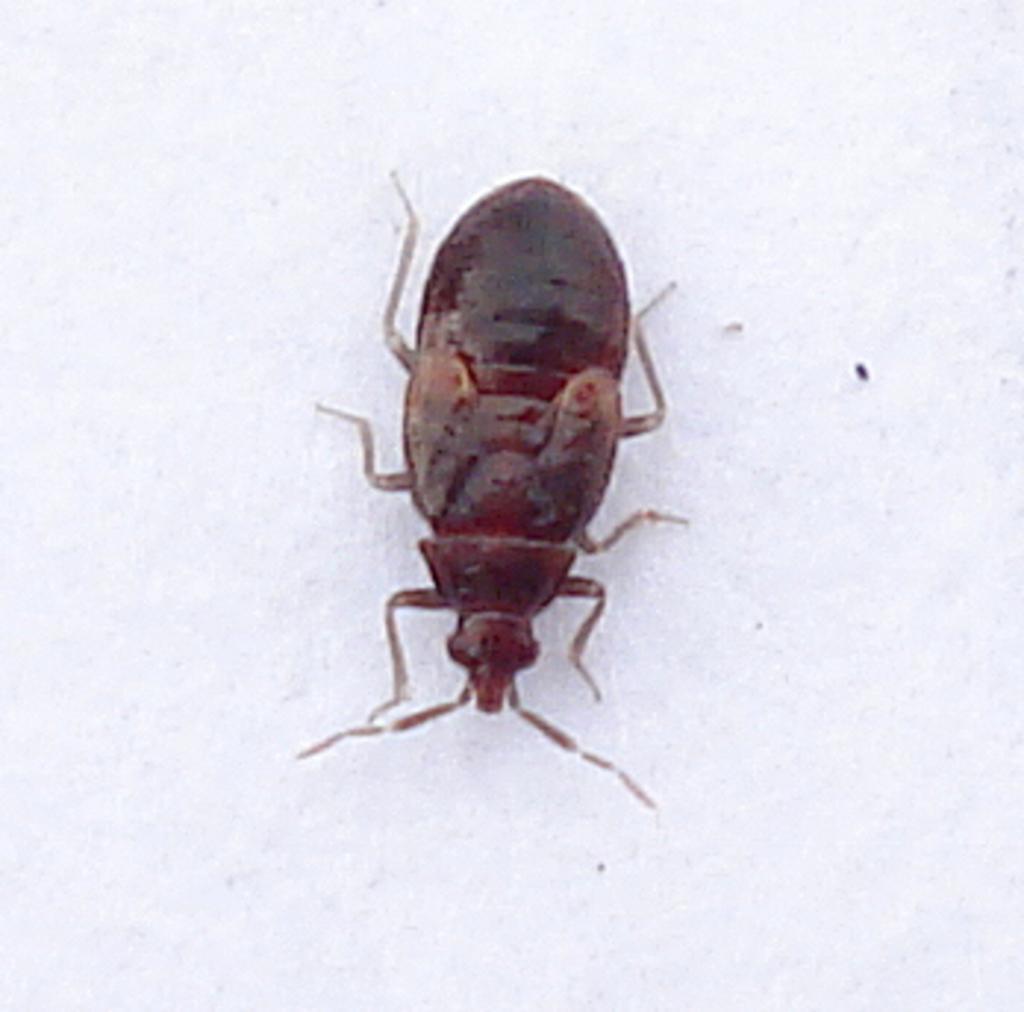Describe this image in one or two sentences. In this image I can see white color thing and on it I can see a brown color cockroach. 